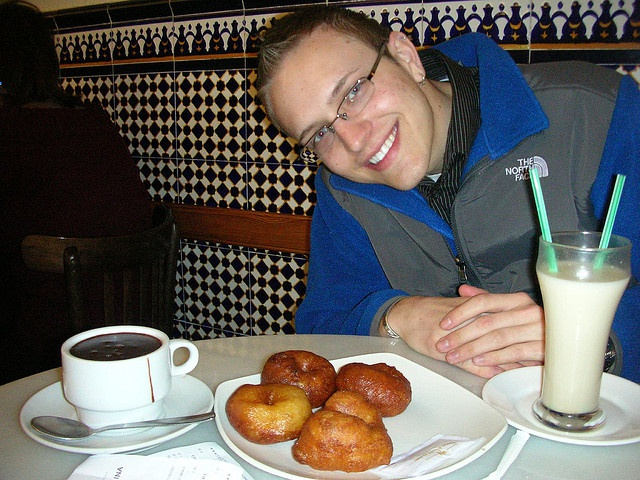Describe the objects in this image and their specific colors. I can see people in black, purple, navy, and tan tones, people in black and gray tones, dining table in black, darkgray, white, and gray tones, cup in black, beige, darkgray, and gray tones, and cup in black, white, gray, and darkgray tones in this image. 